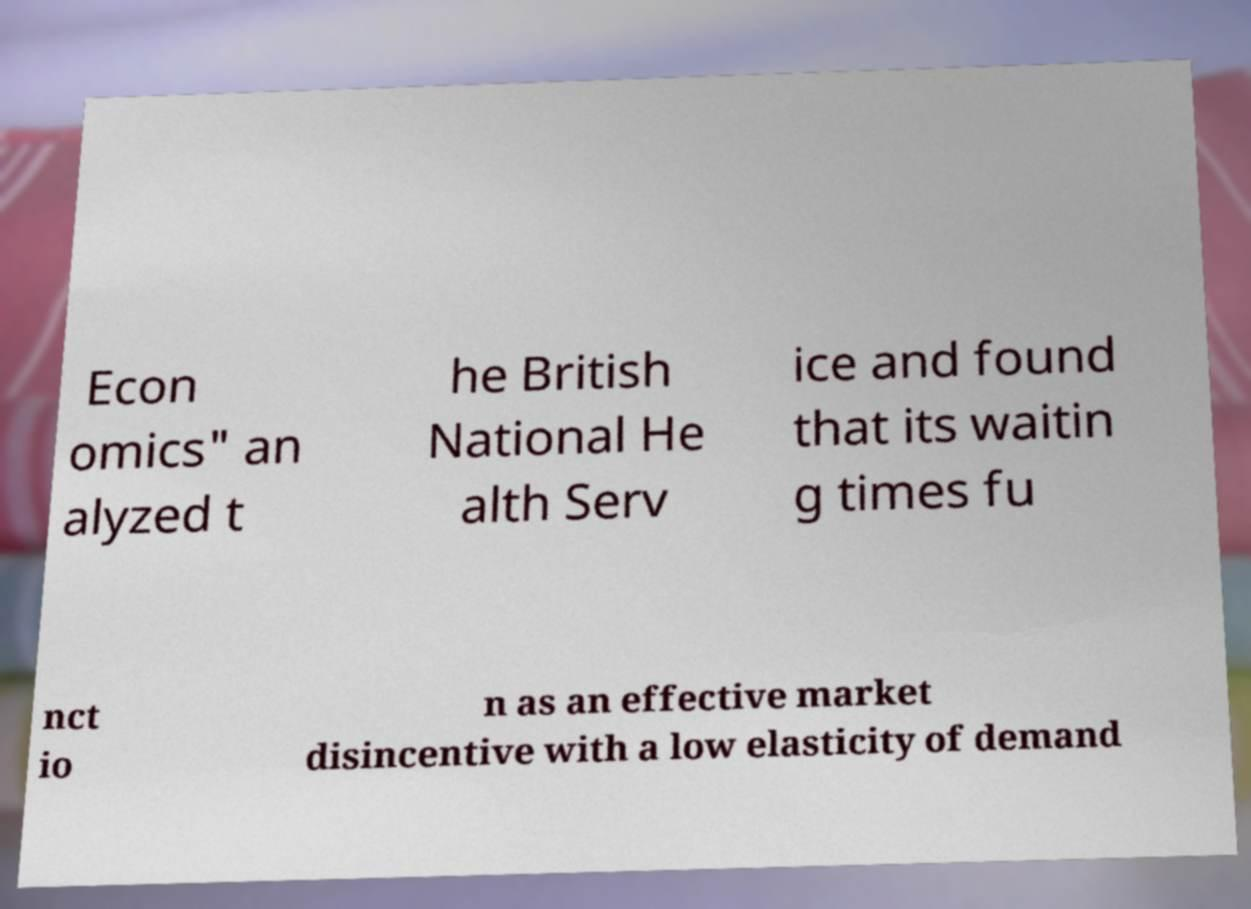Please read and relay the text visible in this image. What does it say? Econ omics" an alyzed t he British National He alth Serv ice and found that its waitin g times fu nct io n as an effective market disincentive with a low elasticity of demand 